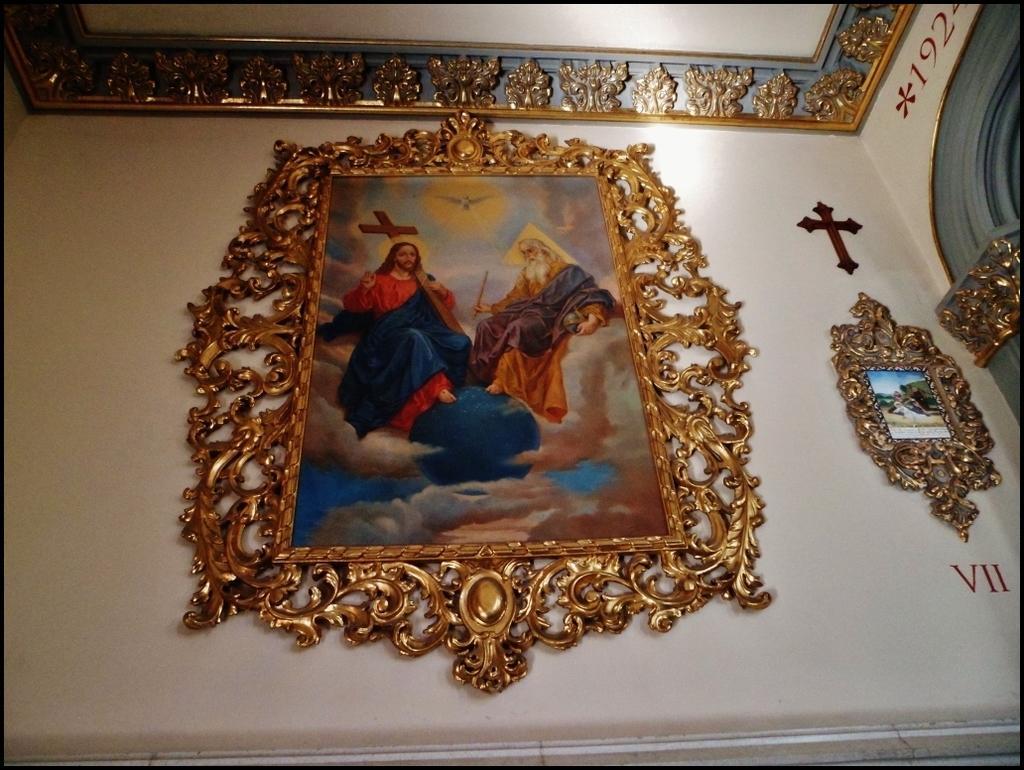Can you describe this image briefly? In this picture we can see frames, christian cross symbol and text on the wall. At the top of the image we can see metal objects. 